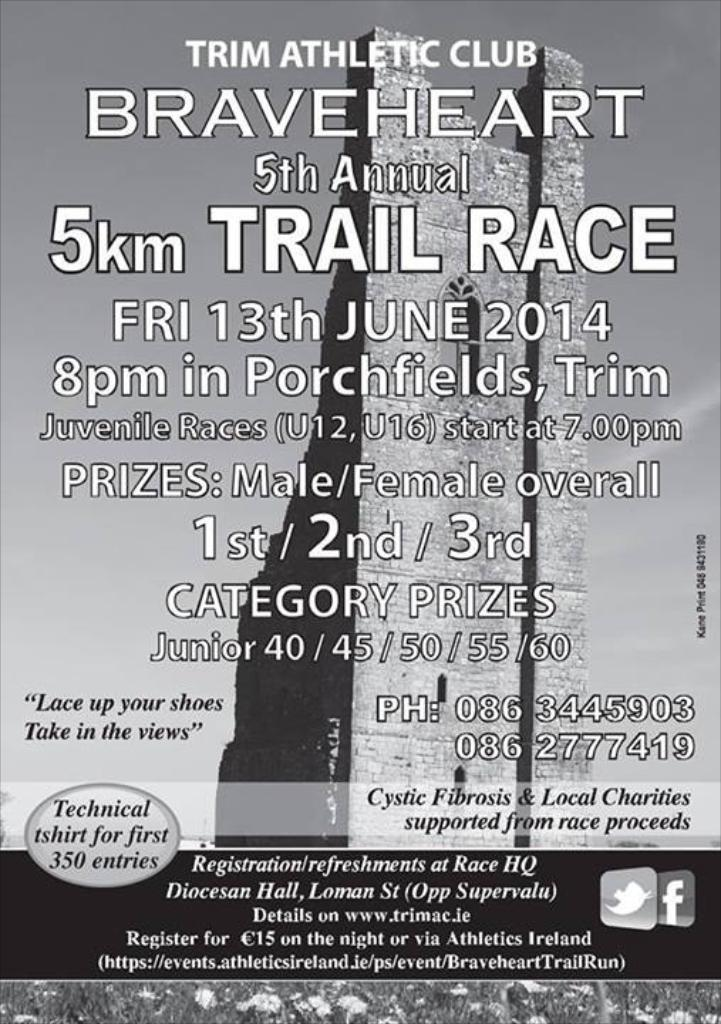<image>
Present a compact description of the photo's key features. An Irish advert for the 5th Annual 5km Trail Race 